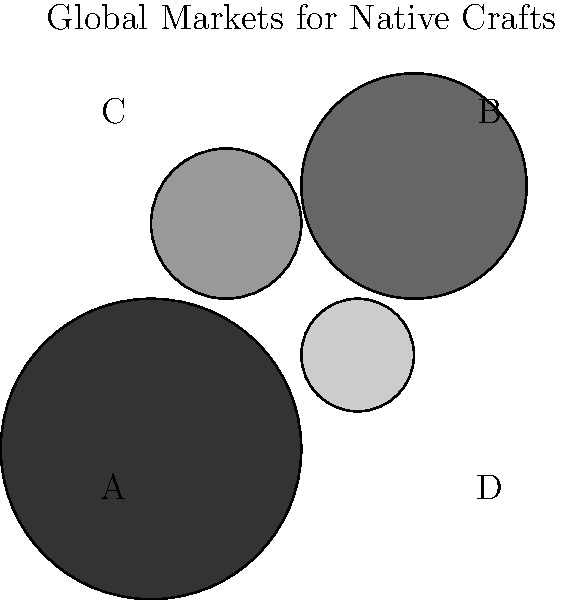Based on the map highlighting potential global markets for native crafts, which region should be prioritized for marketing efforts to maximize global reach and potential sales? To determine which region should be prioritized for marketing efforts, we need to analyze the map and consider the following factors:

1. Market size: Larger regions on the map represent larger potential markets.
2. Market saturation: Darker shades might indicate more saturated markets or higher competition.
3. Global reach: We want to target a region that can serve as a gateway to other markets.

Analyzing the regions:

A. Largest circle, lightest shade: This represents the biggest market with potentially less competition. It could be an emerging market with high growth potential.

B. Second-largest circle, second-darkest shade: This is a sizable market, but the darker shade might indicate higher competition or market saturation.

C. Third-largest circle, second-lightest shade: This market is smaller than A and B but might have less competition than B.

D. Smallest circle, darkest shade: This represents the smallest market with potentially high saturation or competition.

Given these observations:

1. Region A offers the largest potential market with seemingly less competition, making it an attractive option for initial marketing efforts.
2. Its size suggests it could have a significant impact on global reach.
3. The lighter shade indicates there might be more room for growth and less established competition.

Therefore, prioritizing Region A for marketing efforts would likely maximize global reach and potential sales for native crafts.
Answer: Region A 